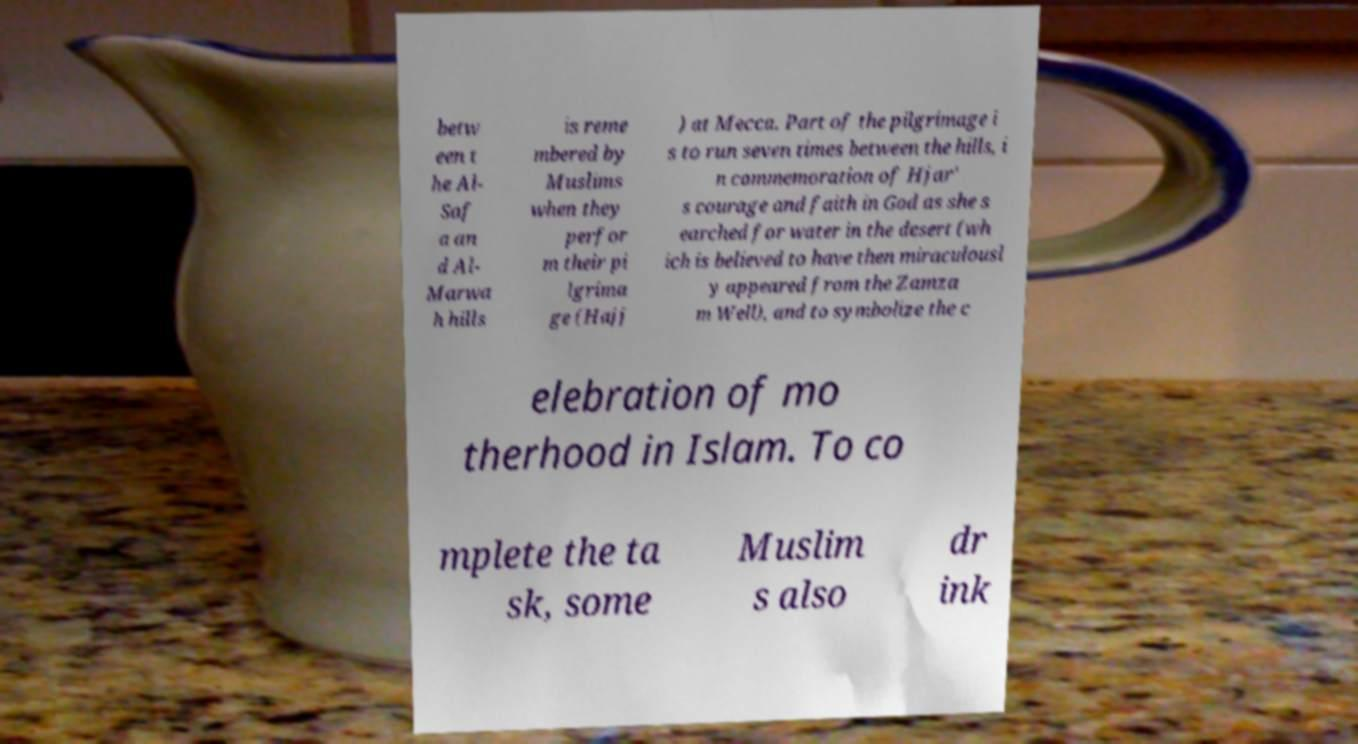For documentation purposes, I need the text within this image transcribed. Could you provide that? betw een t he Al- Saf a an d Al- Marwa h hills is reme mbered by Muslims when they perfor m their pi lgrima ge (Hajj ) at Mecca. Part of the pilgrimage i s to run seven times between the hills, i n commemoration of Hjar' s courage and faith in God as she s earched for water in the desert (wh ich is believed to have then miraculousl y appeared from the Zamza m Well), and to symbolize the c elebration of mo therhood in Islam. To co mplete the ta sk, some Muslim s also dr ink 